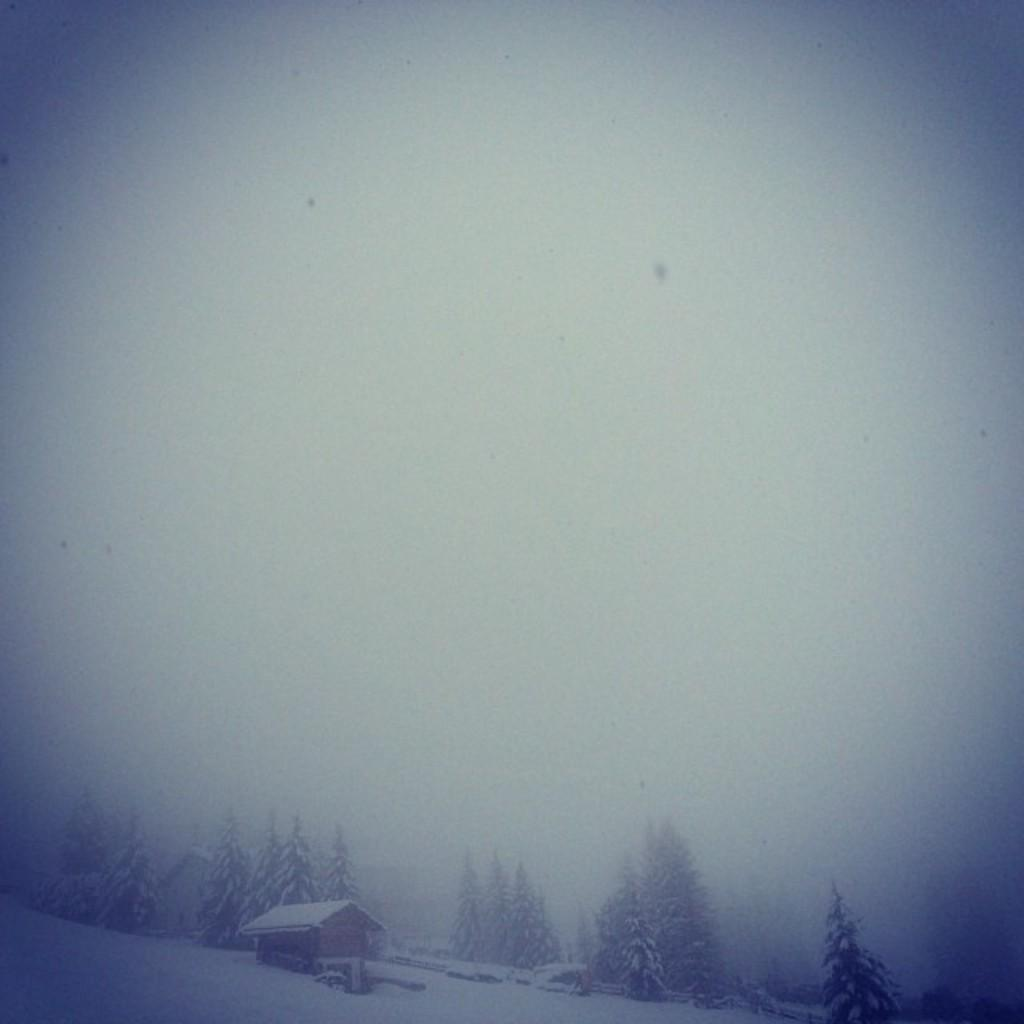What type of structure is visible in the image? There is a house in the image. What natural elements can be seen in the image? There are trees in the image. How is the land depicted in the image? The land in the image is covered with snow. Where is the jar of honey located in the image? There is no jar of honey present in the image. How does the ant navigate through the snow in the image? There are no ants present in the image, so it is not possible to determine how an ant would navigate through the snow. 